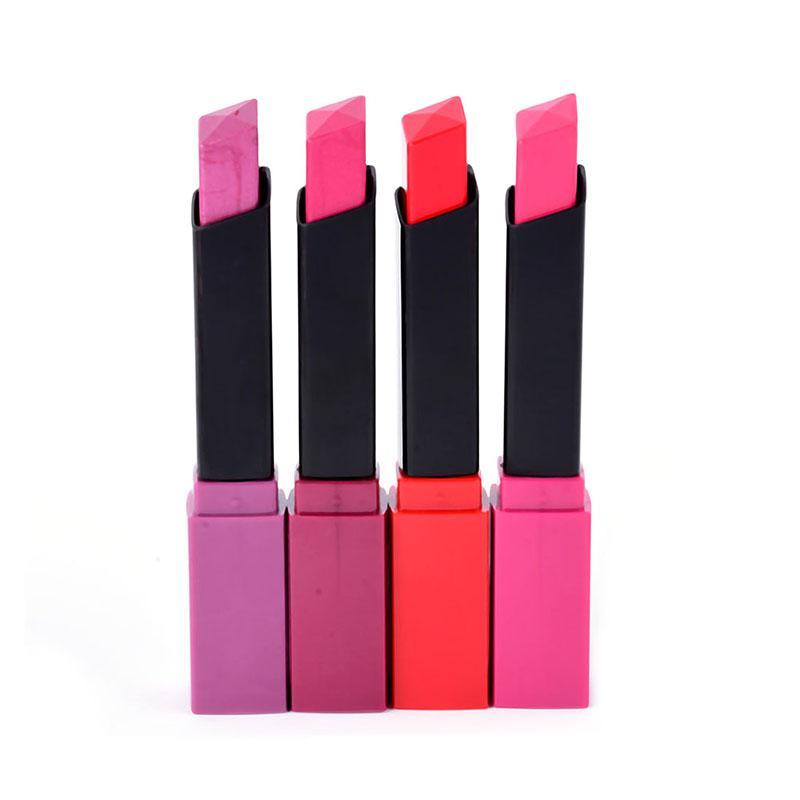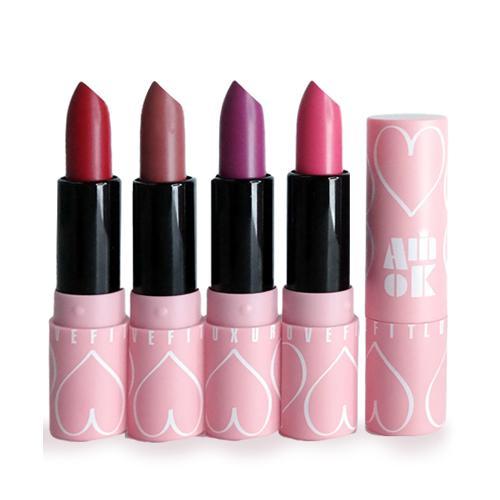The first image is the image on the left, the second image is the image on the right. Examine the images to the left and right. Is the description "Each image in the pair shows the same number of uncapped lipsticks." accurate? Answer yes or no. Yes. 